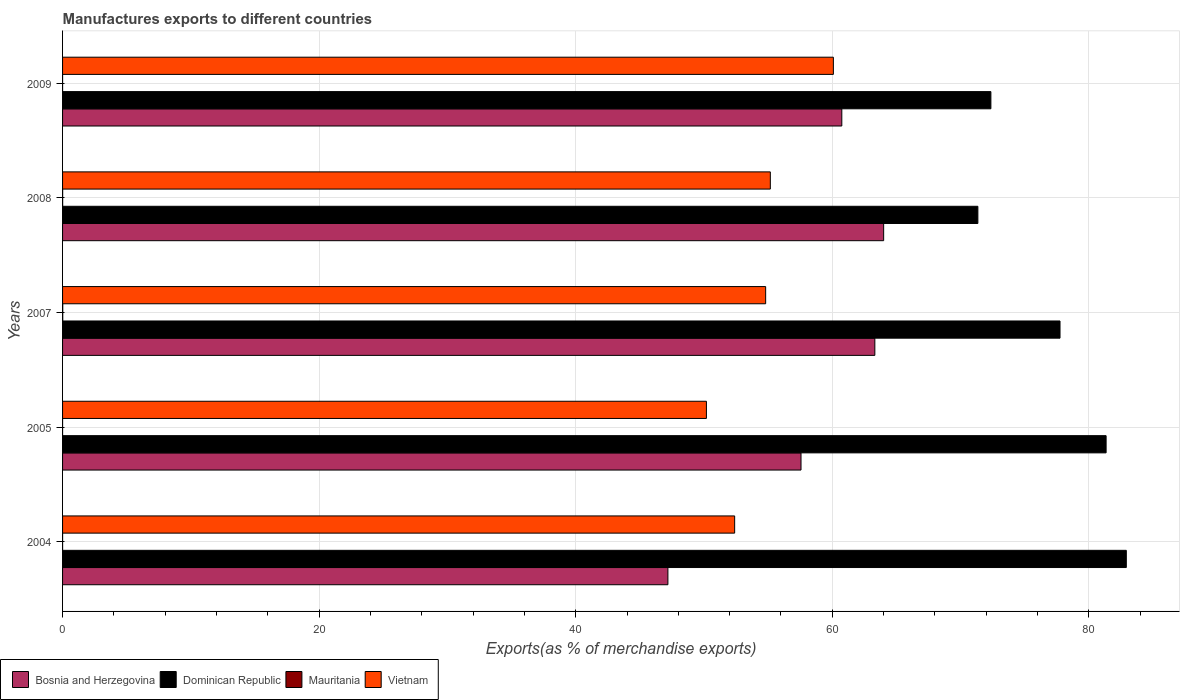How many different coloured bars are there?
Offer a terse response. 4. How many groups of bars are there?
Make the answer very short. 5. Are the number of bars per tick equal to the number of legend labels?
Keep it short and to the point. Yes. How many bars are there on the 3rd tick from the top?
Provide a short and direct response. 4. What is the percentage of exports to different countries in Mauritania in 2005?
Your response must be concise. 0. Across all years, what is the maximum percentage of exports to different countries in Dominican Republic?
Make the answer very short. 82.92. Across all years, what is the minimum percentage of exports to different countries in Bosnia and Herzegovina?
Provide a succinct answer. 47.19. In which year was the percentage of exports to different countries in Bosnia and Herzegovina maximum?
Keep it short and to the point. 2008. What is the total percentage of exports to different countries in Bosnia and Herzegovina in the graph?
Your answer should be compact. 292.82. What is the difference between the percentage of exports to different countries in Dominican Republic in 2005 and that in 2009?
Make the answer very short. 8.98. What is the difference between the percentage of exports to different countries in Dominican Republic in 2005 and the percentage of exports to different countries in Bosnia and Herzegovina in 2008?
Your answer should be compact. 17.34. What is the average percentage of exports to different countries in Mauritania per year?
Your response must be concise. 0. In the year 2008, what is the difference between the percentage of exports to different countries in Bosnia and Herzegovina and percentage of exports to different countries in Dominican Republic?
Your response must be concise. -7.34. In how many years, is the percentage of exports to different countries in Dominican Republic greater than 44 %?
Give a very brief answer. 5. What is the ratio of the percentage of exports to different countries in Vietnam in 2005 to that in 2008?
Your answer should be very brief. 0.91. What is the difference between the highest and the second highest percentage of exports to different countries in Bosnia and Herzegovina?
Provide a succinct answer. 0.69. What is the difference between the highest and the lowest percentage of exports to different countries in Bosnia and Herzegovina?
Your answer should be very brief. 16.82. Is the sum of the percentage of exports to different countries in Vietnam in 2007 and 2009 greater than the maximum percentage of exports to different countries in Mauritania across all years?
Your response must be concise. Yes. What does the 4th bar from the top in 2009 represents?
Provide a short and direct response. Bosnia and Herzegovina. What does the 3rd bar from the bottom in 2009 represents?
Offer a very short reply. Mauritania. Is it the case that in every year, the sum of the percentage of exports to different countries in Mauritania and percentage of exports to different countries in Dominican Republic is greater than the percentage of exports to different countries in Bosnia and Herzegovina?
Offer a very short reply. Yes. How many years are there in the graph?
Offer a very short reply. 5. Are the values on the major ticks of X-axis written in scientific E-notation?
Keep it short and to the point. No. Does the graph contain any zero values?
Provide a short and direct response. No. Does the graph contain grids?
Provide a short and direct response. Yes. Where does the legend appear in the graph?
Your answer should be compact. Bottom left. How many legend labels are there?
Your answer should be compact. 4. What is the title of the graph?
Make the answer very short. Manufactures exports to different countries. What is the label or title of the X-axis?
Your response must be concise. Exports(as % of merchandise exports). What is the label or title of the Y-axis?
Keep it short and to the point. Years. What is the Exports(as % of merchandise exports) in Bosnia and Herzegovina in 2004?
Make the answer very short. 47.19. What is the Exports(as % of merchandise exports) in Dominican Republic in 2004?
Ensure brevity in your answer.  82.92. What is the Exports(as % of merchandise exports) in Mauritania in 2004?
Your response must be concise. 0. What is the Exports(as % of merchandise exports) of Vietnam in 2004?
Keep it short and to the point. 52.39. What is the Exports(as % of merchandise exports) of Bosnia and Herzegovina in 2005?
Your answer should be compact. 57.56. What is the Exports(as % of merchandise exports) of Dominican Republic in 2005?
Offer a terse response. 81.35. What is the Exports(as % of merchandise exports) of Mauritania in 2005?
Offer a very short reply. 0. What is the Exports(as % of merchandise exports) of Vietnam in 2005?
Ensure brevity in your answer.  50.19. What is the Exports(as % of merchandise exports) in Bosnia and Herzegovina in 2007?
Make the answer very short. 63.32. What is the Exports(as % of merchandise exports) in Dominican Republic in 2007?
Provide a short and direct response. 77.75. What is the Exports(as % of merchandise exports) in Mauritania in 2007?
Offer a terse response. 0.01. What is the Exports(as % of merchandise exports) of Vietnam in 2007?
Your response must be concise. 54.81. What is the Exports(as % of merchandise exports) in Bosnia and Herzegovina in 2008?
Offer a very short reply. 64. What is the Exports(as % of merchandise exports) in Dominican Republic in 2008?
Offer a very short reply. 71.35. What is the Exports(as % of merchandise exports) of Mauritania in 2008?
Give a very brief answer. 0.01. What is the Exports(as % of merchandise exports) in Vietnam in 2008?
Give a very brief answer. 55.17. What is the Exports(as % of merchandise exports) in Bosnia and Herzegovina in 2009?
Your answer should be compact. 60.74. What is the Exports(as % of merchandise exports) of Dominican Republic in 2009?
Your answer should be very brief. 72.36. What is the Exports(as % of merchandise exports) of Mauritania in 2009?
Your answer should be very brief. 0. What is the Exports(as % of merchandise exports) in Vietnam in 2009?
Provide a short and direct response. 60.09. Across all years, what is the maximum Exports(as % of merchandise exports) in Bosnia and Herzegovina?
Offer a very short reply. 64. Across all years, what is the maximum Exports(as % of merchandise exports) of Dominican Republic?
Your response must be concise. 82.92. Across all years, what is the maximum Exports(as % of merchandise exports) in Mauritania?
Offer a terse response. 0.01. Across all years, what is the maximum Exports(as % of merchandise exports) of Vietnam?
Ensure brevity in your answer.  60.09. Across all years, what is the minimum Exports(as % of merchandise exports) in Bosnia and Herzegovina?
Your response must be concise. 47.19. Across all years, what is the minimum Exports(as % of merchandise exports) of Dominican Republic?
Provide a succinct answer. 71.35. Across all years, what is the minimum Exports(as % of merchandise exports) of Mauritania?
Your response must be concise. 0. Across all years, what is the minimum Exports(as % of merchandise exports) in Vietnam?
Your answer should be compact. 50.19. What is the total Exports(as % of merchandise exports) of Bosnia and Herzegovina in the graph?
Your answer should be compact. 292.82. What is the total Exports(as % of merchandise exports) of Dominican Republic in the graph?
Offer a very short reply. 385.73. What is the total Exports(as % of merchandise exports) of Mauritania in the graph?
Offer a very short reply. 0.02. What is the total Exports(as % of merchandise exports) in Vietnam in the graph?
Offer a terse response. 272.64. What is the difference between the Exports(as % of merchandise exports) of Bosnia and Herzegovina in 2004 and that in 2005?
Your answer should be compact. -10.38. What is the difference between the Exports(as % of merchandise exports) in Dominican Republic in 2004 and that in 2005?
Give a very brief answer. 1.57. What is the difference between the Exports(as % of merchandise exports) of Mauritania in 2004 and that in 2005?
Offer a very short reply. 0. What is the difference between the Exports(as % of merchandise exports) in Vietnam in 2004 and that in 2005?
Make the answer very short. 2.2. What is the difference between the Exports(as % of merchandise exports) of Bosnia and Herzegovina in 2004 and that in 2007?
Keep it short and to the point. -16.13. What is the difference between the Exports(as % of merchandise exports) in Dominican Republic in 2004 and that in 2007?
Your response must be concise. 5.17. What is the difference between the Exports(as % of merchandise exports) in Mauritania in 2004 and that in 2007?
Make the answer very short. -0.01. What is the difference between the Exports(as % of merchandise exports) of Vietnam in 2004 and that in 2007?
Your answer should be very brief. -2.42. What is the difference between the Exports(as % of merchandise exports) in Bosnia and Herzegovina in 2004 and that in 2008?
Your answer should be compact. -16.82. What is the difference between the Exports(as % of merchandise exports) of Dominican Republic in 2004 and that in 2008?
Ensure brevity in your answer.  11.57. What is the difference between the Exports(as % of merchandise exports) in Mauritania in 2004 and that in 2008?
Ensure brevity in your answer.  -0.01. What is the difference between the Exports(as % of merchandise exports) of Vietnam in 2004 and that in 2008?
Give a very brief answer. -2.78. What is the difference between the Exports(as % of merchandise exports) in Bosnia and Herzegovina in 2004 and that in 2009?
Provide a short and direct response. -13.56. What is the difference between the Exports(as % of merchandise exports) in Dominican Republic in 2004 and that in 2009?
Make the answer very short. 10.56. What is the difference between the Exports(as % of merchandise exports) of Mauritania in 2004 and that in 2009?
Your response must be concise. 0. What is the difference between the Exports(as % of merchandise exports) in Vietnam in 2004 and that in 2009?
Your answer should be compact. -7.69. What is the difference between the Exports(as % of merchandise exports) of Bosnia and Herzegovina in 2005 and that in 2007?
Provide a succinct answer. -5.76. What is the difference between the Exports(as % of merchandise exports) of Dominican Republic in 2005 and that in 2007?
Ensure brevity in your answer.  3.59. What is the difference between the Exports(as % of merchandise exports) in Mauritania in 2005 and that in 2007?
Make the answer very short. -0.01. What is the difference between the Exports(as % of merchandise exports) in Vietnam in 2005 and that in 2007?
Ensure brevity in your answer.  -4.62. What is the difference between the Exports(as % of merchandise exports) of Bosnia and Herzegovina in 2005 and that in 2008?
Your answer should be compact. -6.44. What is the difference between the Exports(as % of merchandise exports) in Dominican Republic in 2005 and that in 2008?
Ensure brevity in your answer.  10. What is the difference between the Exports(as % of merchandise exports) in Mauritania in 2005 and that in 2008?
Give a very brief answer. -0.01. What is the difference between the Exports(as % of merchandise exports) in Vietnam in 2005 and that in 2008?
Ensure brevity in your answer.  -4.98. What is the difference between the Exports(as % of merchandise exports) in Bosnia and Herzegovina in 2005 and that in 2009?
Offer a very short reply. -3.18. What is the difference between the Exports(as % of merchandise exports) of Dominican Republic in 2005 and that in 2009?
Make the answer very short. 8.98. What is the difference between the Exports(as % of merchandise exports) of Mauritania in 2005 and that in 2009?
Offer a terse response. -0. What is the difference between the Exports(as % of merchandise exports) of Vietnam in 2005 and that in 2009?
Provide a succinct answer. -9.9. What is the difference between the Exports(as % of merchandise exports) of Bosnia and Herzegovina in 2007 and that in 2008?
Offer a terse response. -0.69. What is the difference between the Exports(as % of merchandise exports) of Dominican Republic in 2007 and that in 2008?
Your answer should be very brief. 6.4. What is the difference between the Exports(as % of merchandise exports) in Mauritania in 2007 and that in 2008?
Give a very brief answer. 0.01. What is the difference between the Exports(as % of merchandise exports) of Vietnam in 2007 and that in 2008?
Provide a short and direct response. -0.36. What is the difference between the Exports(as % of merchandise exports) in Bosnia and Herzegovina in 2007 and that in 2009?
Ensure brevity in your answer.  2.58. What is the difference between the Exports(as % of merchandise exports) of Dominican Republic in 2007 and that in 2009?
Offer a very short reply. 5.39. What is the difference between the Exports(as % of merchandise exports) of Mauritania in 2007 and that in 2009?
Offer a terse response. 0.01. What is the difference between the Exports(as % of merchandise exports) of Vietnam in 2007 and that in 2009?
Your answer should be compact. -5.28. What is the difference between the Exports(as % of merchandise exports) in Bosnia and Herzegovina in 2008 and that in 2009?
Your answer should be very brief. 3.26. What is the difference between the Exports(as % of merchandise exports) of Dominican Republic in 2008 and that in 2009?
Keep it short and to the point. -1.01. What is the difference between the Exports(as % of merchandise exports) in Mauritania in 2008 and that in 2009?
Offer a terse response. 0.01. What is the difference between the Exports(as % of merchandise exports) of Vietnam in 2008 and that in 2009?
Offer a terse response. -4.91. What is the difference between the Exports(as % of merchandise exports) in Bosnia and Herzegovina in 2004 and the Exports(as % of merchandise exports) in Dominican Republic in 2005?
Give a very brief answer. -34.16. What is the difference between the Exports(as % of merchandise exports) in Bosnia and Herzegovina in 2004 and the Exports(as % of merchandise exports) in Mauritania in 2005?
Provide a succinct answer. 47.19. What is the difference between the Exports(as % of merchandise exports) of Bosnia and Herzegovina in 2004 and the Exports(as % of merchandise exports) of Vietnam in 2005?
Ensure brevity in your answer.  -3. What is the difference between the Exports(as % of merchandise exports) in Dominican Republic in 2004 and the Exports(as % of merchandise exports) in Mauritania in 2005?
Your response must be concise. 82.92. What is the difference between the Exports(as % of merchandise exports) of Dominican Republic in 2004 and the Exports(as % of merchandise exports) of Vietnam in 2005?
Keep it short and to the point. 32.73. What is the difference between the Exports(as % of merchandise exports) of Mauritania in 2004 and the Exports(as % of merchandise exports) of Vietnam in 2005?
Give a very brief answer. -50.19. What is the difference between the Exports(as % of merchandise exports) of Bosnia and Herzegovina in 2004 and the Exports(as % of merchandise exports) of Dominican Republic in 2007?
Your answer should be compact. -30.57. What is the difference between the Exports(as % of merchandise exports) in Bosnia and Herzegovina in 2004 and the Exports(as % of merchandise exports) in Mauritania in 2007?
Provide a succinct answer. 47.17. What is the difference between the Exports(as % of merchandise exports) of Bosnia and Herzegovina in 2004 and the Exports(as % of merchandise exports) of Vietnam in 2007?
Give a very brief answer. -7.62. What is the difference between the Exports(as % of merchandise exports) in Dominican Republic in 2004 and the Exports(as % of merchandise exports) in Mauritania in 2007?
Provide a short and direct response. 82.91. What is the difference between the Exports(as % of merchandise exports) in Dominican Republic in 2004 and the Exports(as % of merchandise exports) in Vietnam in 2007?
Your answer should be very brief. 28.11. What is the difference between the Exports(as % of merchandise exports) of Mauritania in 2004 and the Exports(as % of merchandise exports) of Vietnam in 2007?
Provide a short and direct response. -54.81. What is the difference between the Exports(as % of merchandise exports) of Bosnia and Herzegovina in 2004 and the Exports(as % of merchandise exports) of Dominican Republic in 2008?
Give a very brief answer. -24.16. What is the difference between the Exports(as % of merchandise exports) of Bosnia and Herzegovina in 2004 and the Exports(as % of merchandise exports) of Mauritania in 2008?
Keep it short and to the point. 47.18. What is the difference between the Exports(as % of merchandise exports) of Bosnia and Herzegovina in 2004 and the Exports(as % of merchandise exports) of Vietnam in 2008?
Give a very brief answer. -7.98. What is the difference between the Exports(as % of merchandise exports) in Dominican Republic in 2004 and the Exports(as % of merchandise exports) in Mauritania in 2008?
Offer a very short reply. 82.91. What is the difference between the Exports(as % of merchandise exports) in Dominican Republic in 2004 and the Exports(as % of merchandise exports) in Vietnam in 2008?
Provide a short and direct response. 27.75. What is the difference between the Exports(as % of merchandise exports) in Mauritania in 2004 and the Exports(as % of merchandise exports) in Vietnam in 2008?
Keep it short and to the point. -55.17. What is the difference between the Exports(as % of merchandise exports) in Bosnia and Herzegovina in 2004 and the Exports(as % of merchandise exports) in Dominican Republic in 2009?
Provide a short and direct response. -25.18. What is the difference between the Exports(as % of merchandise exports) of Bosnia and Herzegovina in 2004 and the Exports(as % of merchandise exports) of Mauritania in 2009?
Give a very brief answer. 47.19. What is the difference between the Exports(as % of merchandise exports) in Bosnia and Herzegovina in 2004 and the Exports(as % of merchandise exports) in Vietnam in 2009?
Offer a terse response. -12.9. What is the difference between the Exports(as % of merchandise exports) of Dominican Republic in 2004 and the Exports(as % of merchandise exports) of Mauritania in 2009?
Keep it short and to the point. 82.92. What is the difference between the Exports(as % of merchandise exports) in Dominican Republic in 2004 and the Exports(as % of merchandise exports) in Vietnam in 2009?
Your response must be concise. 22.84. What is the difference between the Exports(as % of merchandise exports) of Mauritania in 2004 and the Exports(as % of merchandise exports) of Vietnam in 2009?
Your answer should be very brief. -60.08. What is the difference between the Exports(as % of merchandise exports) of Bosnia and Herzegovina in 2005 and the Exports(as % of merchandise exports) of Dominican Republic in 2007?
Keep it short and to the point. -20.19. What is the difference between the Exports(as % of merchandise exports) in Bosnia and Herzegovina in 2005 and the Exports(as % of merchandise exports) in Mauritania in 2007?
Offer a terse response. 57.55. What is the difference between the Exports(as % of merchandise exports) in Bosnia and Herzegovina in 2005 and the Exports(as % of merchandise exports) in Vietnam in 2007?
Keep it short and to the point. 2.76. What is the difference between the Exports(as % of merchandise exports) in Dominican Republic in 2005 and the Exports(as % of merchandise exports) in Mauritania in 2007?
Provide a succinct answer. 81.33. What is the difference between the Exports(as % of merchandise exports) of Dominican Republic in 2005 and the Exports(as % of merchandise exports) of Vietnam in 2007?
Offer a very short reply. 26.54. What is the difference between the Exports(as % of merchandise exports) of Mauritania in 2005 and the Exports(as % of merchandise exports) of Vietnam in 2007?
Your answer should be compact. -54.81. What is the difference between the Exports(as % of merchandise exports) in Bosnia and Herzegovina in 2005 and the Exports(as % of merchandise exports) in Dominican Republic in 2008?
Offer a very short reply. -13.79. What is the difference between the Exports(as % of merchandise exports) of Bosnia and Herzegovina in 2005 and the Exports(as % of merchandise exports) of Mauritania in 2008?
Your answer should be very brief. 57.56. What is the difference between the Exports(as % of merchandise exports) in Bosnia and Herzegovina in 2005 and the Exports(as % of merchandise exports) in Vietnam in 2008?
Ensure brevity in your answer.  2.39. What is the difference between the Exports(as % of merchandise exports) of Dominican Republic in 2005 and the Exports(as % of merchandise exports) of Mauritania in 2008?
Offer a very short reply. 81.34. What is the difference between the Exports(as % of merchandise exports) of Dominican Republic in 2005 and the Exports(as % of merchandise exports) of Vietnam in 2008?
Give a very brief answer. 26.17. What is the difference between the Exports(as % of merchandise exports) in Mauritania in 2005 and the Exports(as % of merchandise exports) in Vietnam in 2008?
Your answer should be very brief. -55.17. What is the difference between the Exports(as % of merchandise exports) of Bosnia and Herzegovina in 2005 and the Exports(as % of merchandise exports) of Dominican Republic in 2009?
Provide a succinct answer. -14.8. What is the difference between the Exports(as % of merchandise exports) in Bosnia and Herzegovina in 2005 and the Exports(as % of merchandise exports) in Mauritania in 2009?
Make the answer very short. 57.56. What is the difference between the Exports(as % of merchandise exports) of Bosnia and Herzegovina in 2005 and the Exports(as % of merchandise exports) of Vietnam in 2009?
Provide a short and direct response. -2.52. What is the difference between the Exports(as % of merchandise exports) in Dominican Republic in 2005 and the Exports(as % of merchandise exports) in Mauritania in 2009?
Offer a terse response. 81.34. What is the difference between the Exports(as % of merchandise exports) of Dominican Republic in 2005 and the Exports(as % of merchandise exports) of Vietnam in 2009?
Offer a terse response. 21.26. What is the difference between the Exports(as % of merchandise exports) of Mauritania in 2005 and the Exports(as % of merchandise exports) of Vietnam in 2009?
Provide a short and direct response. -60.08. What is the difference between the Exports(as % of merchandise exports) of Bosnia and Herzegovina in 2007 and the Exports(as % of merchandise exports) of Dominican Republic in 2008?
Your response must be concise. -8.03. What is the difference between the Exports(as % of merchandise exports) of Bosnia and Herzegovina in 2007 and the Exports(as % of merchandise exports) of Mauritania in 2008?
Provide a succinct answer. 63.31. What is the difference between the Exports(as % of merchandise exports) in Bosnia and Herzegovina in 2007 and the Exports(as % of merchandise exports) in Vietnam in 2008?
Keep it short and to the point. 8.15. What is the difference between the Exports(as % of merchandise exports) of Dominican Republic in 2007 and the Exports(as % of merchandise exports) of Mauritania in 2008?
Provide a short and direct response. 77.75. What is the difference between the Exports(as % of merchandise exports) in Dominican Republic in 2007 and the Exports(as % of merchandise exports) in Vietnam in 2008?
Make the answer very short. 22.58. What is the difference between the Exports(as % of merchandise exports) in Mauritania in 2007 and the Exports(as % of merchandise exports) in Vietnam in 2008?
Provide a succinct answer. -55.16. What is the difference between the Exports(as % of merchandise exports) in Bosnia and Herzegovina in 2007 and the Exports(as % of merchandise exports) in Dominican Republic in 2009?
Offer a terse response. -9.05. What is the difference between the Exports(as % of merchandise exports) of Bosnia and Herzegovina in 2007 and the Exports(as % of merchandise exports) of Mauritania in 2009?
Make the answer very short. 63.32. What is the difference between the Exports(as % of merchandise exports) of Bosnia and Herzegovina in 2007 and the Exports(as % of merchandise exports) of Vietnam in 2009?
Offer a very short reply. 3.23. What is the difference between the Exports(as % of merchandise exports) of Dominican Republic in 2007 and the Exports(as % of merchandise exports) of Mauritania in 2009?
Your answer should be very brief. 77.75. What is the difference between the Exports(as % of merchandise exports) of Dominican Republic in 2007 and the Exports(as % of merchandise exports) of Vietnam in 2009?
Provide a succinct answer. 17.67. What is the difference between the Exports(as % of merchandise exports) in Mauritania in 2007 and the Exports(as % of merchandise exports) in Vietnam in 2009?
Make the answer very short. -60.07. What is the difference between the Exports(as % of merchandise exports) in Bosnia and Herzegovina in 2008 and the Exports(as % of merchandise exports) in Dominican Republic in 2009?
Keep it short and to the point. -8.36. What is the difference between the Exports(as % of merchandise exports) in Bosnia and Herzegovina in 2008 and the Exports(as % of merchandise exports) in Mauritania in 2009?
Make the answer very short. 64. What is the difference between the Exports(as % of merchandise exports) of Bosnia and Herzegovina in 2008 and the Exports(as % of merchandise exports) of Vietnam in 2009?
Make the answer very short. 3.92. What is the difference between the Exports(as % of merchandise exports) in Dominican Republic in 2008 and the Exports(as % of merchandise exports) in Mauritania in 2009?
Keep it short and to the point. 71.35. What is the difference between the Exports(as % of merchandise exports) of Dominican Republic in 2008 and the Exports(as % of merchandise exports) of Vietnam in 2009?
Provide a succinct answer. 11.26. What is the difference between the Exports(as % of merchandise exports) in Mauritania in 2008 and the Exports(as % of merchandise exports) in Vietnam in 2009?
Ensure brevity in your answer.  -60.08. What is the average Exports(as % of merchandise exports) of Bosnia and Herzegovina per year?
Provide a short and direct response. 58.56. What is the average Exports(as % of merchandise exports) of Dominican Republic per year?
Give a very brief answer. 77.15. What is the average Exports(as % of merchandise exports) in Mauritania per year?
Offer a terse response. 0. What is the average Exports(as % of merchandise exports) in Vietnam per year?
Make the answer very short. 54.53. In the year 2004, what is the difference between the Exports(as % of merchandise exports) in Bosnia and Herzegovina and Exports(as % of merchandise exports) in Dominican Republic?
Your answer should be compact. -35.73. In the year 2004, what is the difference between the Exports(as % of merchandise exports) in Bosnia and Herzegovina and Exports(as % of merchandise exports) in Mauritania?
Your answer should be very brief. 47.19. In the year 2004, what is the difference between the Exports(as % of merchandise exports) of Bosnia and Herzegovina and Exports(as % of merchandise exports) of Vietnam?
Keep it short and to the point. -5.2. In the year 2004, what is the difference between the Exports(as % of merchandise exports) of Dominican Republic and Exports(as % of merchandise exports) of Mauritania?
Give a very brief answer. 82.92. In the year 2004, what is the difference between the Exports(as % of merchandise exports) of Dominican Republic and Exports(as % of merchandise exports) of Vietnam?
Ensure brevity in your answer.  30.53. In the year 2004, what is the difference between the Exports(as % of merchandise exports) of Mauritania and Exports(as % of merchandise exports) of Vietnam?
Your answer should be very brief. -52.39. In the year 2005, what is the difference between the Exports(as % of merchandise exports) in Bosnia and Herzegovina and Exports(as % of merchandise exports) in Dominican Republic?
Provide a short and direct response. -23.78. In the year 2005, what is the difference between the Exports(as % of merchandise exports) in Bosnia and Herzegovina and Exports(as % of merchandise exports) in Mauritania?
Offer a very short reply. 57.56. In the year 2005, what is the difference between the Exports(as % of merchandise exports) in Bosnia and Herzegovina and Exports(as % of merchandise exports) in Vietnam?
Give a very brief answer. 7.37. In the year 2005, what is the difference between the Exports(as % of merchandise exports) in Dominican Republic and Exports(as % of merchandise exports) in Mauritania?
Offer a very short reply. 81.35. In the year 2005, what is the difference between the Exports(as % of merchandise exports) in Dominican Republic and Exports(as % of merchandise exports) in Vietnam?
Your response must be concise. 31.16. In the year 2005, what is the difference between the Exports(as % of merchandise exports) in Mauritania and Exports(as % of merchandise exports) in Vietnam?
Offer a terse response. -50.19. In the year 2007, what is the difference between the Exports(as % of merchandise exports) in Bosnia and Herzegovina and Exports(as % of merchandise exports) in Dominican Republic?
Your answer should be compact. -14.43. In the year 2007, what is the difference between the Exports(as % of merchandise exports) in Bosnia and Herzegovina and Exports(as % of merchandise exports) in Mauritania?
Provide a succinct answer. 63.3. In the year 2007, what is the difference between the Exports(as % of merchandise exports) of Bosnia and Herzegovina and Exports(as % of merchandise exports) of Vietnam?
Your answer should be very brief. 8.51. In the year 2007, what is the difference between the Exports(as % of merchandise exports) of Dominican Republic and Exports(as % of merchandise exports) of Mauritania?
Make the answer very short. 77.74. In the year 2007, what is the difference between the Exports(as % of merchandise exports) in Dominican Republic and Exports(as % of merchandise exports) in Vietnam?
Offer a very short reply. 22.95. In the year 2007, what is the difference between the Exports(as % of merchandise exports) in Mauritania and Exports(as % of merchandise exports) in Vietnam?
Offer a very short reply. -54.79. In the year 2008, what is the difference between the Exports(as % of merchandise exports) in Bosnia and Herzegovina and Exports(as % of merchandise exports) in Dominican Republic?
Provide a short and direct response. -7.34. In the year 2008, what is the difference between the Exports(as % of merchandise exports) of Bosnia and Herzegovina and Exports(as % of merchandise exports) of Mauritania?
Offer a terse response. 64. In the year 2008, what is the difference between the Exports(as % of merchandise exports) of Bosnia and Herzegovina and Exports(as % of merchandise exports) of Vietnam?
Offer a very short reply. 8.83. In the year 2008, what is the difference between the Exports(as % of merchandise exports) in Dominican Republic and Exports(as % of merchandise exports) in Mauritania?
Your response must be concise. 71.34. In the year 2008, what is the difference between the Exports(as % of merchandise exports) of Dominican Republic and Exports(as % of merchandise exports) of Vietnam?
Provide a short and direct response. 16.18. In the year 2008, what is the difference between the Exports(as % of merchandise exports) in Mauritania and Exports(as % of merchandise exports) in Vietnam?
Your answer should be very brief. -55.16. In the year 2009, what is the difference between the Exports(as % of merchandise exports) of Bosnia and Herzegovina and Exports(as % of merchandise exports) of Dominican Republic?
Provide a succinct answer. -11.62. In the year 2009, what is the difference between the Exports(as % of merchandise exports) of Bosnia and Herzegovina and Exports(as % of merchandise exports) of Mauritania?
Your answer should be compact. 60.74. In the year 2009, what is the difference between the Exports(as % of merchandise exports) in Bosnia and Herzegovina and Exports(as % of merchandise exports) in Vietnam?
Offer a terse response. 0.66. In the year 2009, what is the difference between the Exports(as % of merchandise exports) in Dominican Republic and Exports(as % of merchandise exports) in Mauritania?
Offer a very short reply. 72.36. In the year 2009, what is the difference between the Exports(as % of merchandise exports) of Dominican Republic and Exports(as % of merchandise exports) of Vietnam?
Offer a very short reply. 12.28. In the year 2009, what is the difference between the Exports(as % of merchandise exports) of Mauritania and Exports(as % of merchandise exports) of Vietnam?
Your response must be concise. -60.08. What is the ratio of the Exports(as % of merchandise exports) in Bosnia and Herzegovina in 2004 to that in 2005?
Ensure brevity in your answer.  0.82. What is the ratio of the Exports(as % of merchandise exports) in Dominican Republic in 2004 to that in 2005?
Keep it short and to the point. 1.02. What is the ratio of the Exports(as % of merchandise exports) in Mauritania in 2004 to that in 2005?
Offer a very short reply. 3.42. What is the ratio of the Exports(as % of merchandise exports) of Vietnam in 2004 to that in 2005?
Your answer should be very brief. 1.04. What is the ratio of the Exports(as % of merchandise exports) in Bosnia and Herzegovina in 2004 to that in 2007?
Offer a terse response. 0.75. What is the ratio of the Exports(as % of merchandise exports) in Dominican Republic in 2004 to that in 2007?
Your answer should be very brief. 1.07. What is the ratio of the Exports(as % of merchandise exports) in Mauritania in 2004 to that in 2007?
Provide a succinct answer. 0.12. What is the ratio of the Exports(as % of merchandise exports) in Vietnam in 2004 to that in 2007?
Give a very brief answer. 0.96. What is the ratio of the Exports(as % of merchandise exports) in Bosnia and Herzegovina in 2004 to that in 2008?
Your answer should be compact. 0.74. What is the ratio of the Exports(as % of merchandise exports) of Dominican Republic in 2004 to that in 2008?
Provide a succinct answer. 1.16. What is the ratio of the Exports(as % of merchandise exports) of Mauritania in 2004 to that in 2008?
Make the answer very short. 0.23. What is the ratio of the Exports(as % of merchandise exports) of Vietnam in 2004 to that in 2008?
Provide a short and direct response. 0.95. What is the ratio of the Exports(as % of merchandise exports) of Bosnia and Herzegovina in 2004 to that in 2009?
Offer a very short reply. 0.78. What is the ratio of the Exports(as % of merchandise exports) of Dominican Republic in 2004 to that in 2009?
Offer a very short reply. 1.15. What is the ratio of the Exports(as % of merchandise exports) of Mauritania in 2004 to that in 2009?
Provide a short and direct response. 1.62. What is the ratio of the Exports(as % of merchandise exports) in Vietnam in 2004 to that in 2009?
Your answer should be compact. 0.87. What is the ratio of the Exports(as % of merchandise exports) in Bosnia and Herzegovina in 2005 to that in 2007?
Make the answer very short. 0.91. What is the ratio of the Exports(as % of merchandise exports) in Dominican Republic in 2005 to that in 2007?
Your response must be concise. 1.05. What is the ratio of the Exports(as % of merchandise exports) of Mauritania in 2005 to that in 2007?
Offer a very short reply. 0.04. What is the ratio of the Exports(as % of merchandise exports) in Vietnam in 2005 to that in 2007?
Keep it short and to the point. 0.92. What is the ratio of the Exports(as % of merchandise exports) in Bosnia and Herzegovina in 2005 to that in 2008?
Make the answer very short. 0.9. What is the ratio of the Exports(as % of merchandise exports) in Dominican Republic in 2005 to that in 2008?
Your response must be concise. 1.14. What is the ratio of the Exports(as % of merchandise exports) in Mauritania in 2005 to that in 2008?
Offer a terse response. 0.07. What is the ratio of the Exports(as % of merchandise exports) of Vietnam in 2005 to that in 2008?
Your answer should be compact. 0.91. What is the ratio of the Exports(as % of merchandise exports) of Bosnia and Herzegovina in 2005 to that in 2009?
Ensure brevity in your answer.  0.95. What is the ratio of the Exports(as % of merchandise exports) of Dominican Republic in 2005 to that in 2009?
Your response must be concise. 1.12. What is the ratio of the Exports(as % of merchandise exports) in Mauritania in 2005 to that in 2009?
Your answer should be very brief. 0.47. What is the ratio of the Exports(as % of merchandise exports) in Vietnam in 2005 to that in 2009?
Your answer should be compact. 0.84. What is the ratio of the Exports(as % of merchandise exports) in Bosnia and Herzegovina in 2007 to that in 2008?
Make the answer very short. 0.99. What is the ratio of the Exports(as % of merchandise exports) in Dominican Republic in 2007 to that in 2008?
Give a very brief answer. 1.09. What is the ratio of the Exports(as % of merchandise exports) in Mauritania in 2007 to that in 2008?
Offer a very short reply. 1.9. What is the ratio of the Exports(as % of merchandise exports) of Vietnam in 2007 to that in 2008?
Ensure brevity in your answer.  0.99. What is the ratio of the Exports(as % of merchandise exports) in Bosnia and Herzegovina in 2007 to that in 2009?
Keep it short and to the point. 1.04. What is the ratio of the Exports(as % of merchandise exports) of Dominican Republic in 2007 to that in 2009?
Give a very brief answer. 1.07. What is the ratio of the Exports(as % of merchandise exports) of Mauritania in 2007 to that in 2009?
Provide a short and direct response. 13.28. What is the ratio of the Exports(as % of merchandise exports) of Vietnam in 2007 to that in 2009?
Your answer should be very brief. 0.91. What is the ratio of the Exports(as % of merchandise exports) of Bosnia and Herzegovina in 2008 to that in 2009?
Provide a succinct answer. 1.05. What is the ratio of the Exports(as % of merchandise exports) in Mauritania in 2008 to that in 2009?
Provide a succinct answer. 6.97. What is the ratio of the Exports(as % of merchandise exports) of Vietnam in 2008 to that in 2009?
Your answer should be very brief. 0.92. What is the difference between the highest and the second highest Exports(as % of merchandise exports) in Bosnia and Herzegovina?
Provide a succinct answer. 0.69. What is the difference between the highest and the second highest Exports(as % of merchandise exports) of Dominican Republic?
Ensure brevity in your answer.  1.57. What is the difference between the highest and the second highest Exports(as % of merchandise exports) in Mauritania?
Ensure brevity in your answer.  0.01. What is the difference between the highest and the second highest Exports(as % of merchandise exports) in Vietnam?
Offer a terse response. 4.91. What is the difference between the highest and the lowest Exports(as % of merchandise exports) in Bosnia and Herzegovina?
Your answer should be very brief. 16.82. What is the difference between the highest and the lowest Exports(as % of merchandise exports) in Dominican Republic?
Provide a succinct answer. 11.57. What is the difference between the highest and the lowest Exports(as % of merchandise exports) of Mauritania?
Make the answer very short. 0.01. What is the difference between the highest and the lowest Exports(as % of merchandise exports) of Vietnam?
Offer a terse response. 9.9. 